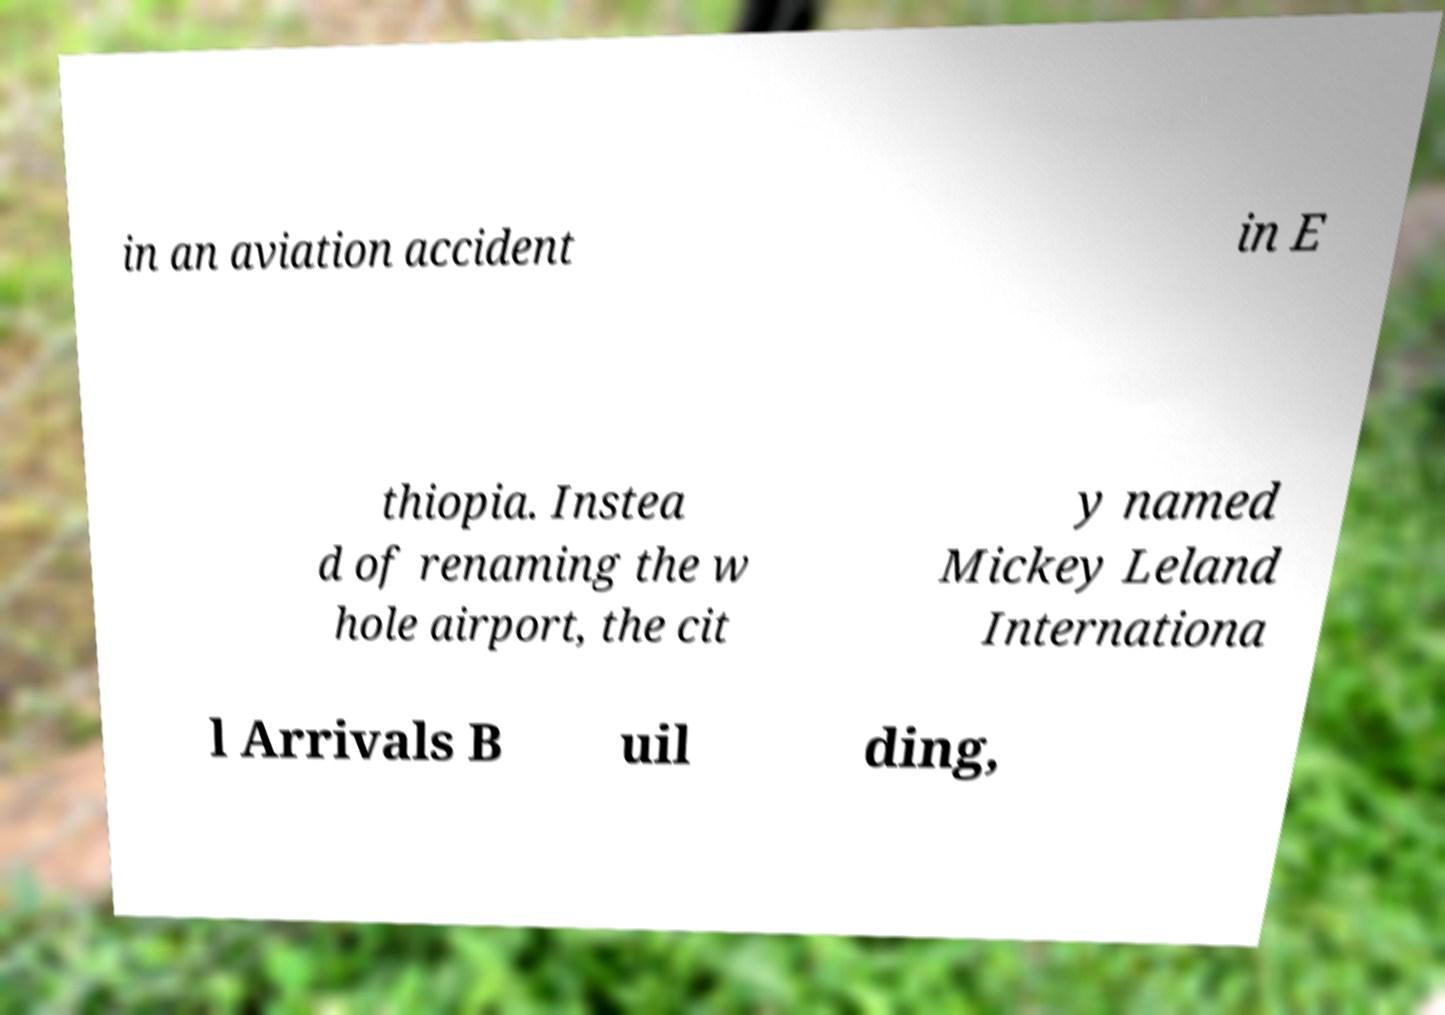What messages or text are displayed in this image? I need them in a readable, typed format. in an aviation accident in E thiopia. Instea d of renaming the w hole airport, the cit y named Mickey Leland Internationa l Arrivals B uil ding, 